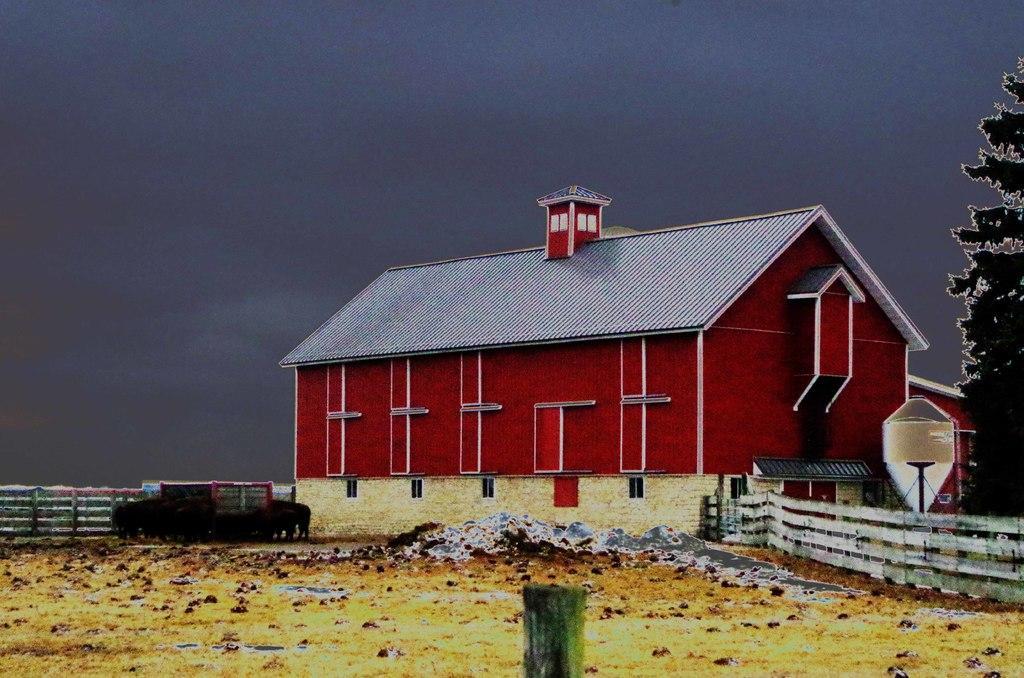Could you give a brief overview of what you see in this image? This image consists of a building in the middle. It is in red color. There is a tree on the right side. There is sky at the top. There is a car in the middle. 